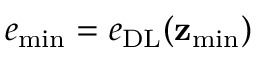Convert formula to latex. <formula><loc_0><loc_0><loc_500><loc_500>e _ { \min } = e _ { D L } ( z _ { \min } )</formula> 